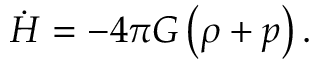<formula> <loc_0><loc_0><loc_500><loc_500>\dot { H } = - 4 \pi G \left ( \rho + p \right ) .</formula> 